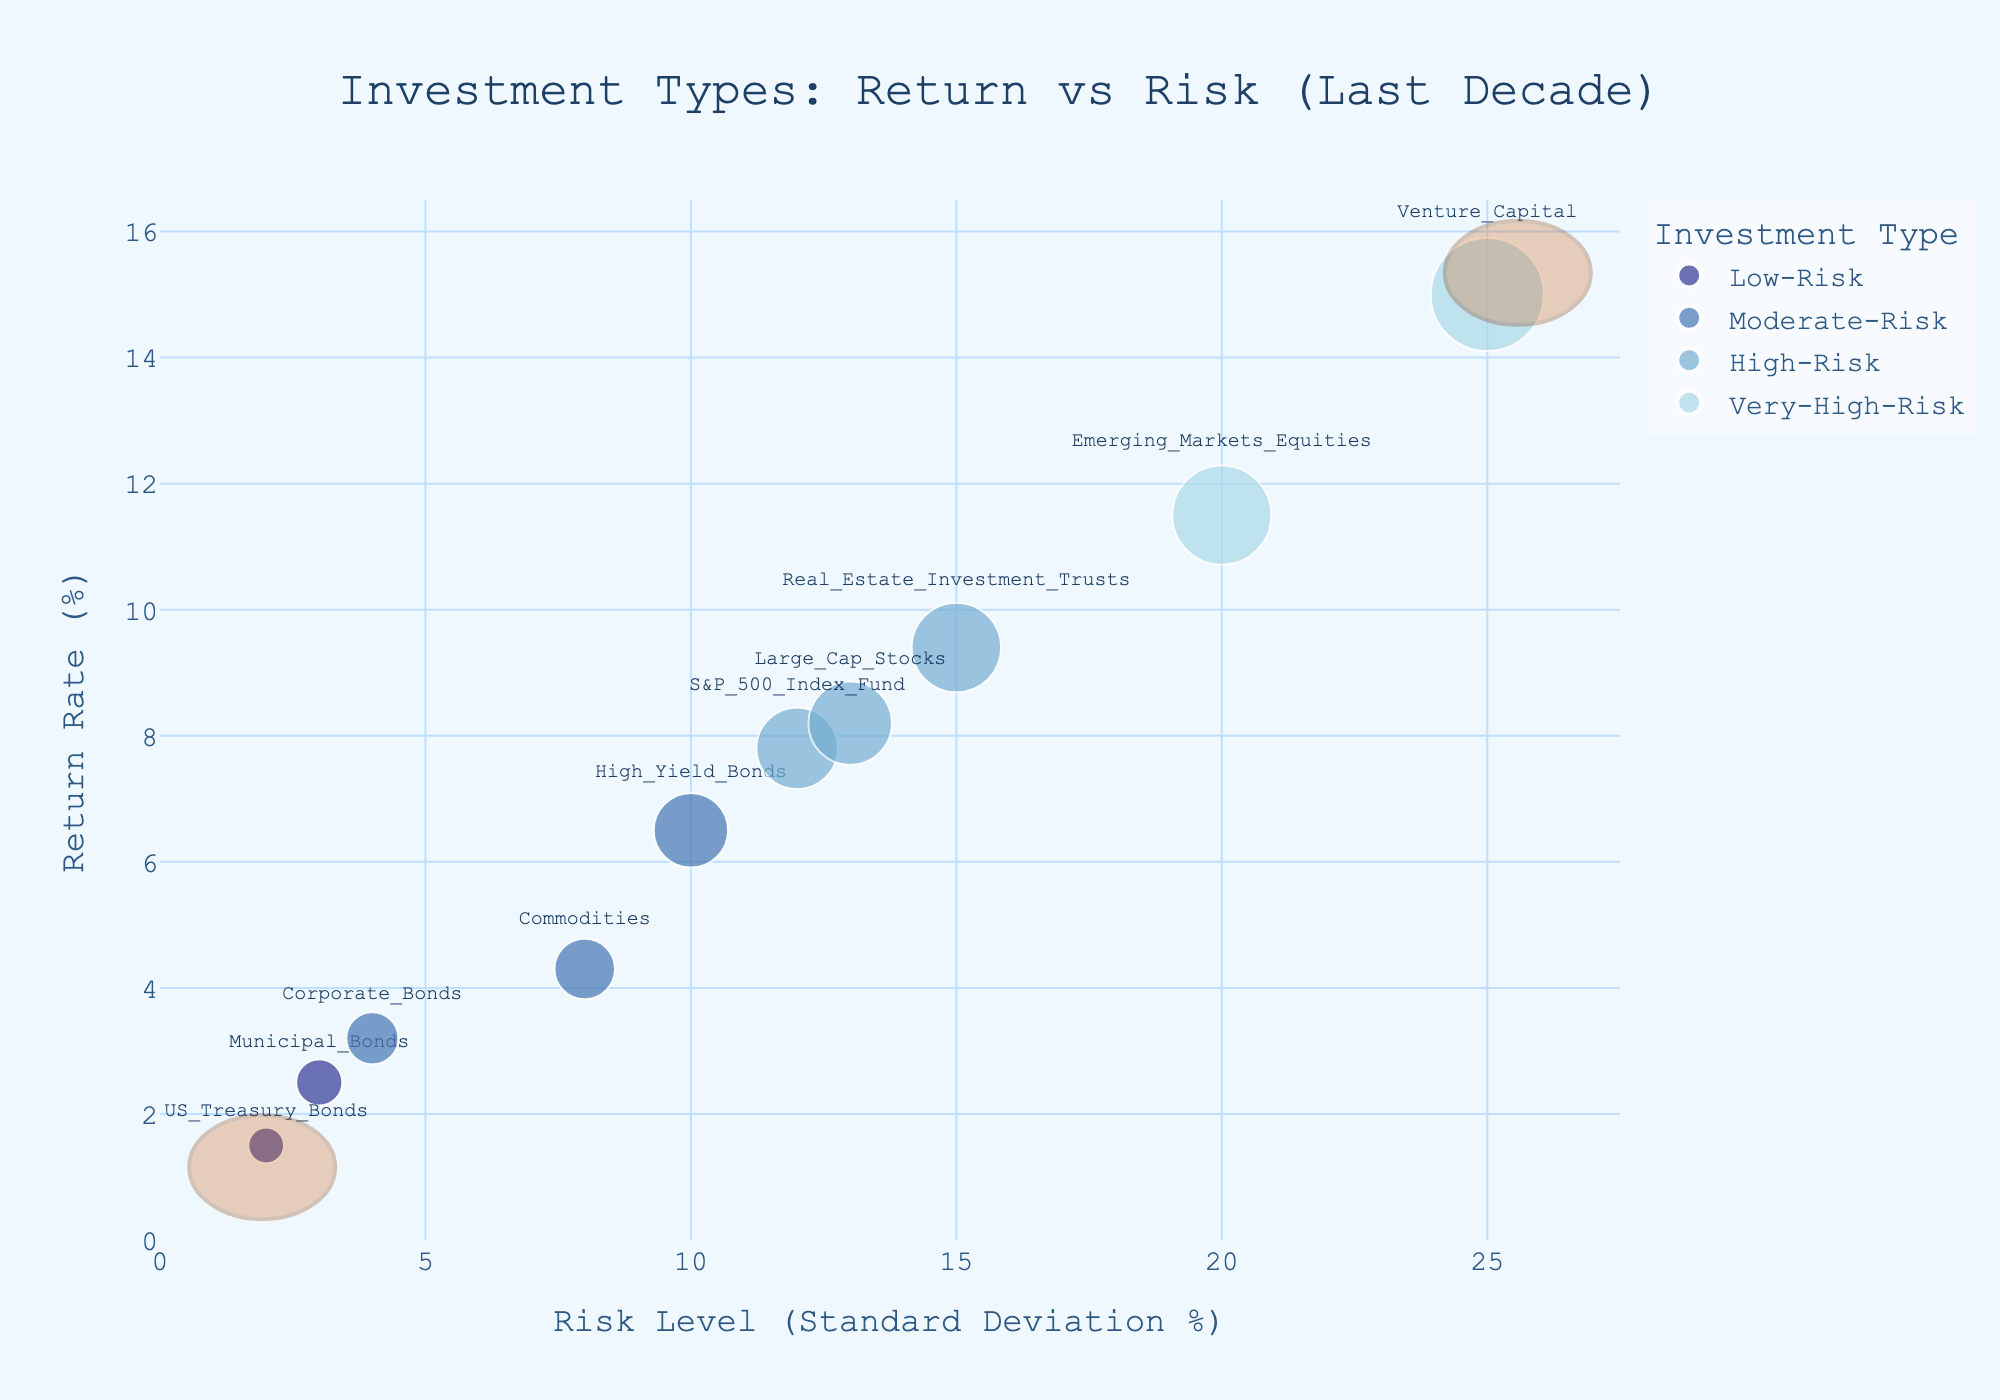What is the title of the chart? The chart title is displayed at the top center of the figure. It reads "Investment Types: Return vs Risk (Last Decade)."
Answer: Investment Types: Return vs Risk (Last Decade) What are the axes labels? The x-axis label is "Risk Level (Standard Deviation %)," and the y-axis label is "Return Rate (%)." These labels describe the two dimensions represented on the chart.
Answer: Risk Level (Standard Deviation %) and Return Rate (%) Which investment type has the highest return rate? To find the investment type with the highest return rate, look for the bubble placed highest on the y-axis. The label shows "Venture_Capital" with a return rate of 15%.
Answer: Venture_Capital Which investment has the lowest risk? To identify the investment with the lowest risk, locate the bubble closest to the left on the x-axis. The label shows "US_Treasury_Bonds" with a risk level of 2%.
Answer: US_Treasury_Bonds Compare the return rates of High Yield Bonds and Commodities. Which one is higher and by how much? Look at the return rate for High_Yield_Bonds (6.5%) and Commodities (4.3%). Subtract the smaller return from the larger return: 6.5% - 4.3% = 2.2%. High_Yield_Bonds has a higher return rate by 2.2%.
Answer: High_Yield_Bonds by 2.2% Which investment type falls in the Moderate-Risk category and has the highest return rate? Among the Moderate-Risk categories, compare Corporate_Bonds (3.2%), High_Yield_Bonds (6.5%), and Commodities (4.3%) by looking at their return rates. High_Yield_Bonds has the highest return rate of 6.5%.
Answer: High_Yield_Bonds What's the combined risk level for the investments in the High-Risk category? Identify High-Risk investments: S&P_500_Index_Fund (12%) and Large_Cap_Stocks (13%). Add their risk levels: 12% + 13% = 25%.
Answer: 25% How does the risk level of Emerging Markets Equities compare to that of Real Estate Investment Trusts? Compare the bubbles for Emerging_Markets_Equities (20%) and Real_Estate_Investment_Trusts (15%) on the x-axis. Emerging_Markets_Equities has a higher risk level than Real_Estate_Investment_Trusts.
Answer: Emerging_Markets_Equities have higher risk How many different risk categories are represented in the chart? Look at the legend on the right side of the chart to count the distinct risk categories. The categories are Low-Risk, Moderate-Risk, High-Risk, and Very-High-Risk, making 4 in total.
Answer: 4 Which investment type offers a higher return with a risk level above 10%: S&P 500 Index Fund or Large Cap Stocks? Compare the return rates of S&P_500_Index_Fund (7.8%) and Large_Cap_Stocks (8.2%), both with risk levels above 10%. Large_Cap_Stocks has a higher return.
Answer: Large_Cap_Stocks 